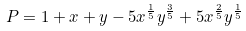Convert formula to latex. <formula><loc_0><loc_0><loc_500><loc_500>P = 1 + x + y - 5 x ^ { \frac { 1 } { 5 } } y ^ { \frac { 3 } { 5 } } + 5 x ^ { \frac { 2 } { 5 } } y ^ { \frac { 1 } { 5 } }</formula> 